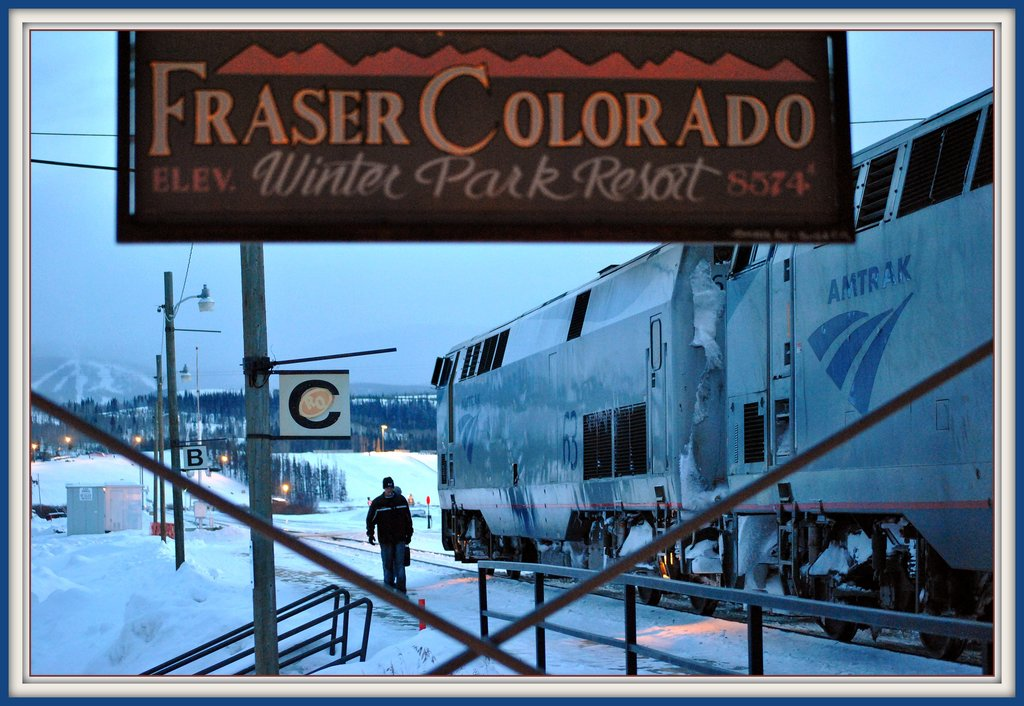What are the key elements in this picture? The image features a dramatic winter scene at a train station in Fraser, Colorado. A large, snow-covered Amtrak train is central to the view, illustrating the area's connection to national rail networks. Dominating the foreground, a sign bearing the text 'Fraser Colorado ELEV. Winter Park Resort 8574' proudly indicates the high altitude and proximity to the popular Winter Park Resort. A lone figure, possibly a passenger or a worker, adds a human element to the scene, walking along the snowy platform. This setting is underscored by the dusky or early dawn light and softened by the serene, snow-laden mountains in the distance, offering a tranquil yet chilly atmosphere typical of Colorado's winter landscape. 